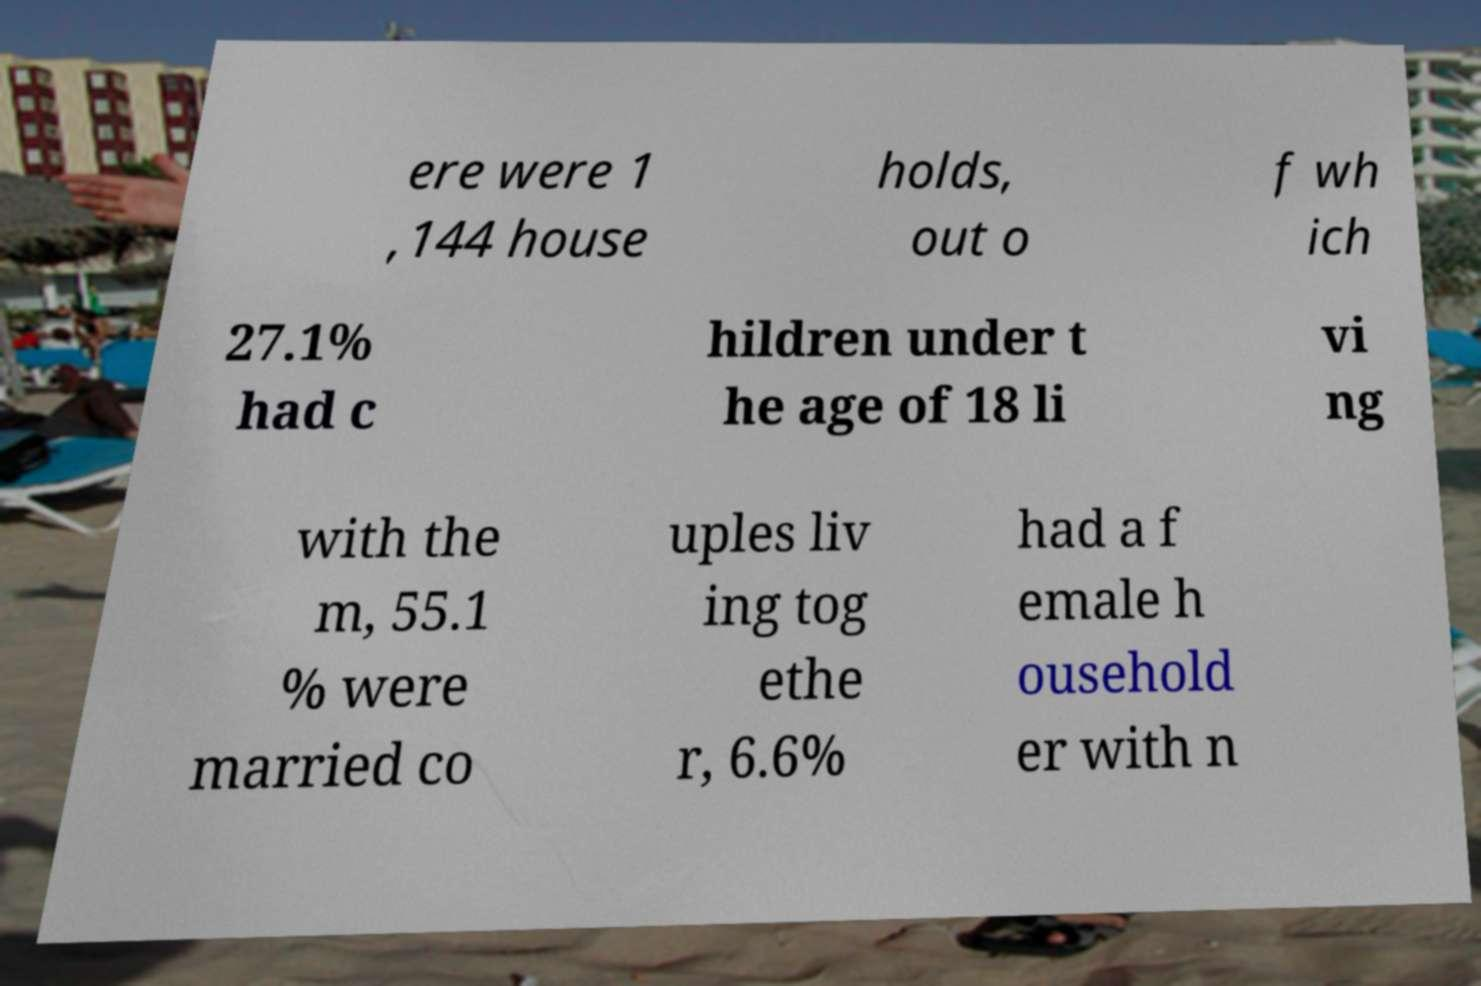Could you assist in decoding the text presented in this image and type it out clearly? ere were 1 ,144 house holds, out o f wh ich 27.1% had c hildren under t he age of 18 li vi ng with the m, 55.1 % were married co uples liv ing tog ethe r, 6.6% had a f emale h ousehold er with n 